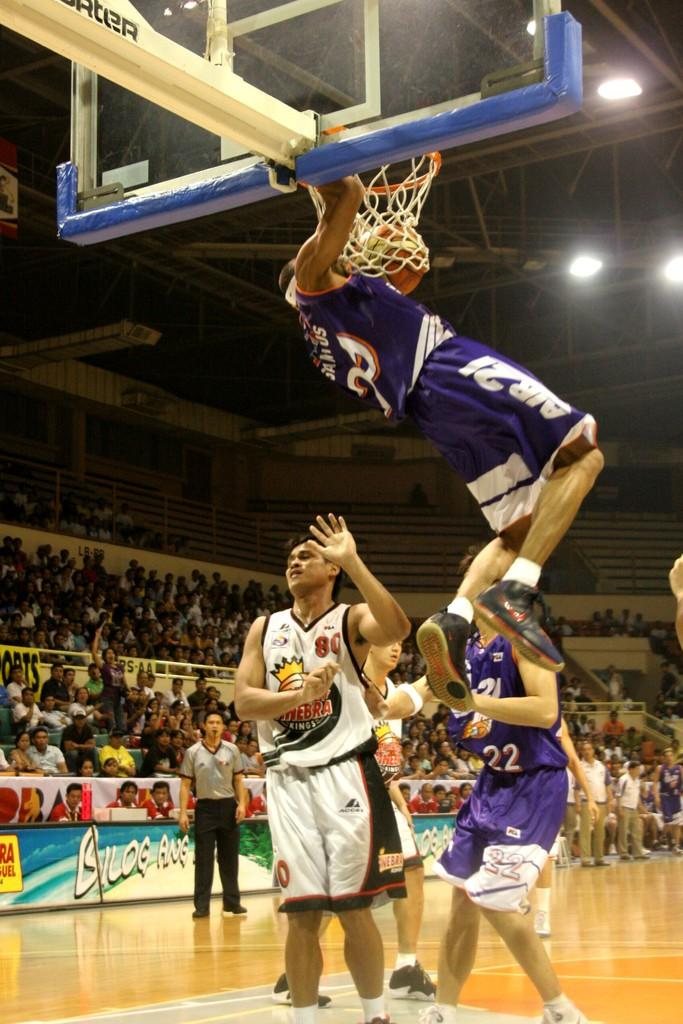<image>
Render a clear and concise summary of the photo. The Kings player is hoping not to have the opposing player fall on top of him. 